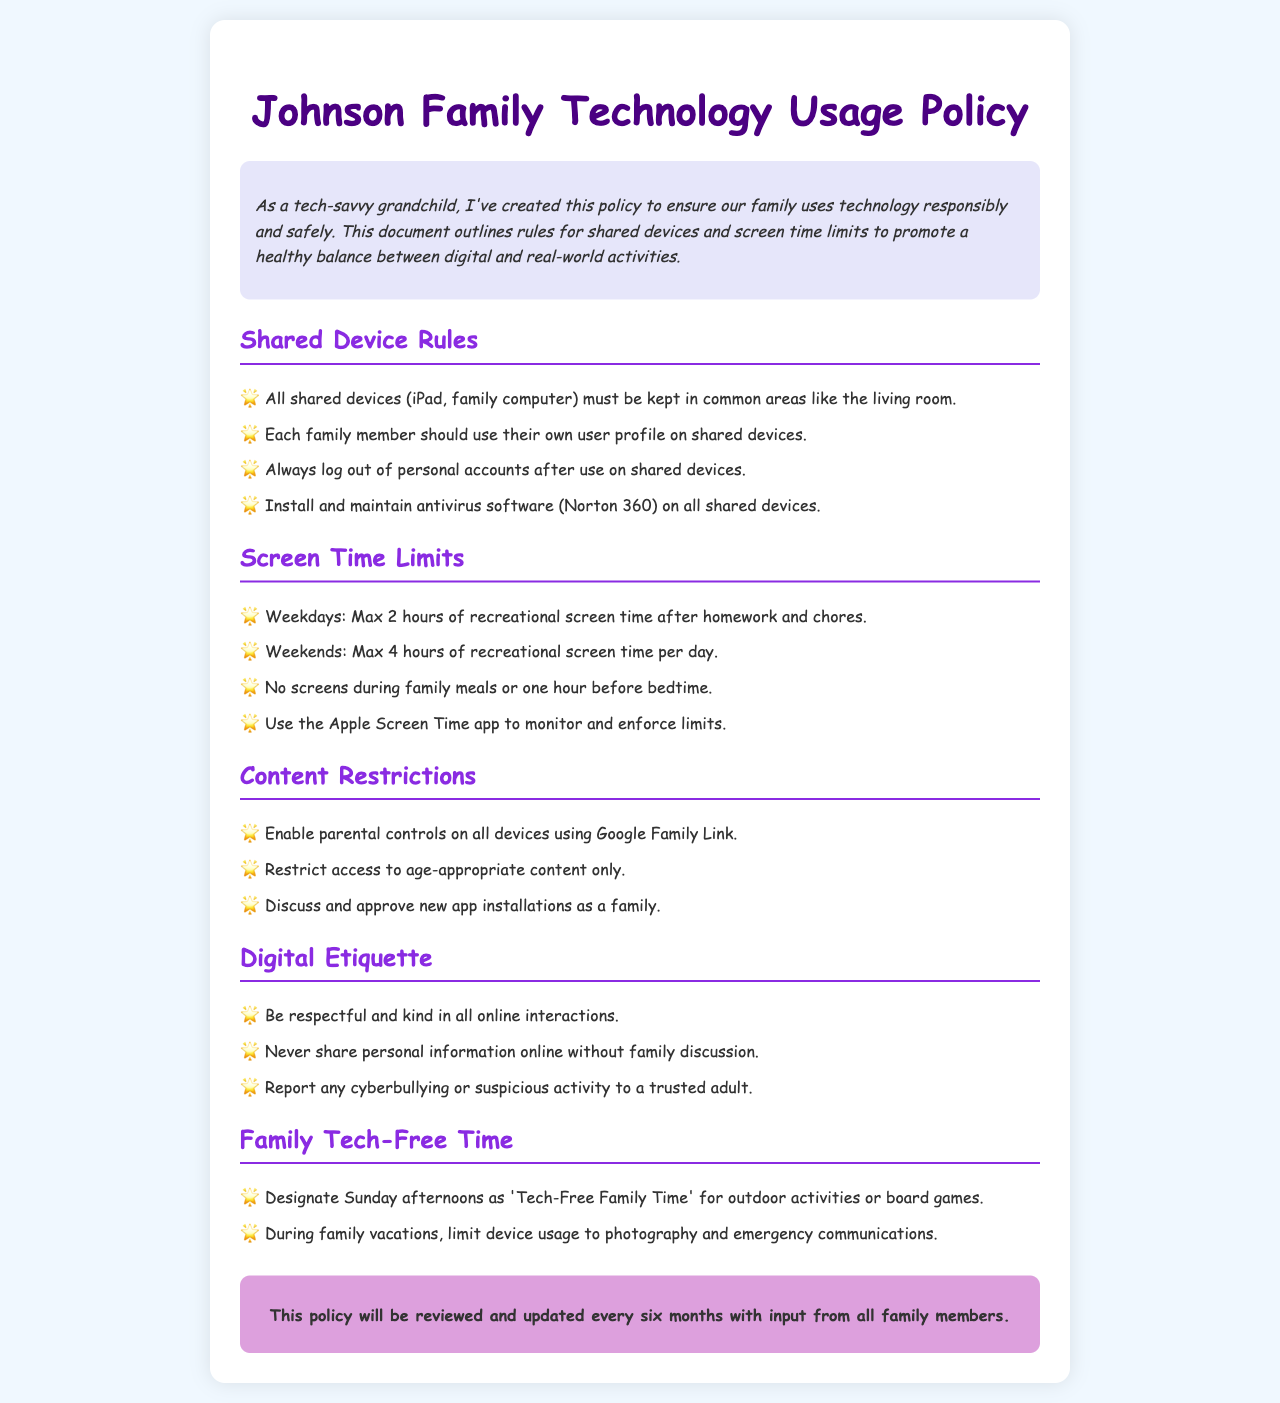What is the maximum recreational screen time allowed on weekdays? The document states that the maximum recreational screen time on weekdays is 2 hours after homework and chores.
Answer: 2 hours Where should all shared devices be kept? The policy indicates that all shared devices must be kept in common areas like the living room.
Answer: Common areas What app should be used to monitor screen time limits? The document specifies using the Apple Screen Time app to monitor and enforce limits.
Answer: Apple Screen Time app What is the duration for Tech-Free Family Time? The policy designates Sunday afternoons as 'Tech-Free Family Time'.
Answer: Sunday afternoons How often will the policy be reviewed? The document mentions that the policy will be reviewed and updated every six months.
Answer: Every six months What is the rule for screens during family meals? The document states that no screens are allowed during family meals.
Answer: No screens How should new app installations be handled? According to the policy, new app installations should be discussed and approved as a family.
Answer: Discussed and approved What software is recommended for antivirus on shared devices? The family technology usage policy recommends installing Norton 360 for antivirus on shared devices.
Answer: Norton 360 